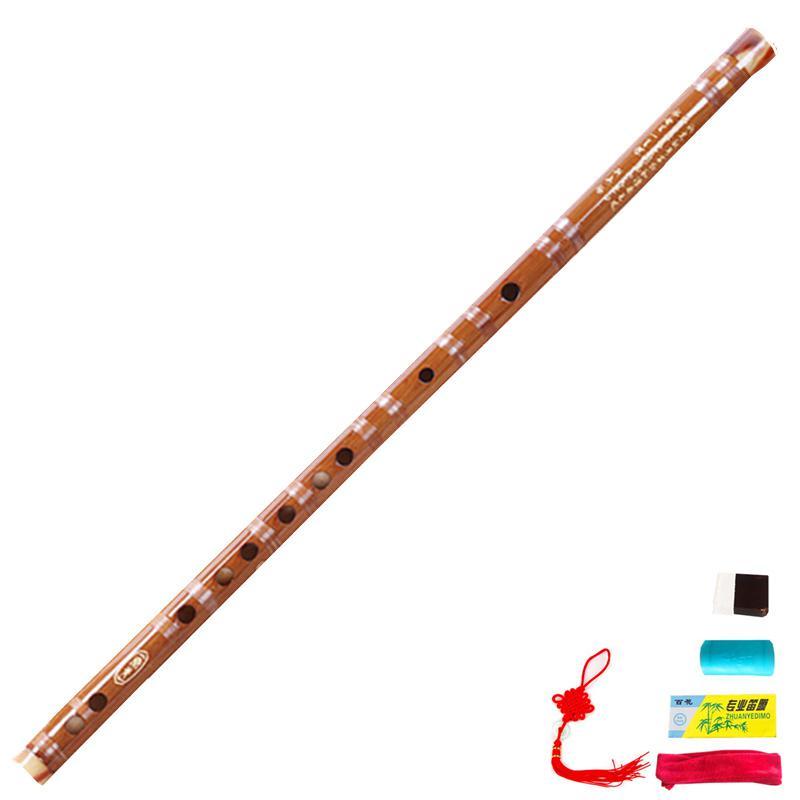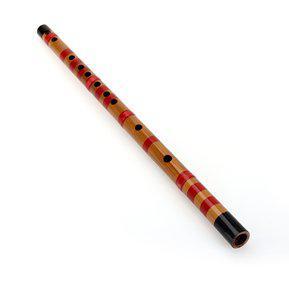The first image is the image on the left, the second image is the image on the right. Examine the images to the left and right. Is the description "There are two disassembled flutes." accurate? Answer yes or no. No. The first image is the image on the left, the second image is the image on the right. Evaluate the accuracy of this statement regarding the images: "The left image shows two flutes side-by-side, displayed diagonally with ends at the upper right.". Is it true? Answer yes or no. No. 